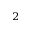Convert formula to latex. <formula><loc_0><loc_0><loc_500><loc_500>^ { 2 }</formula> 